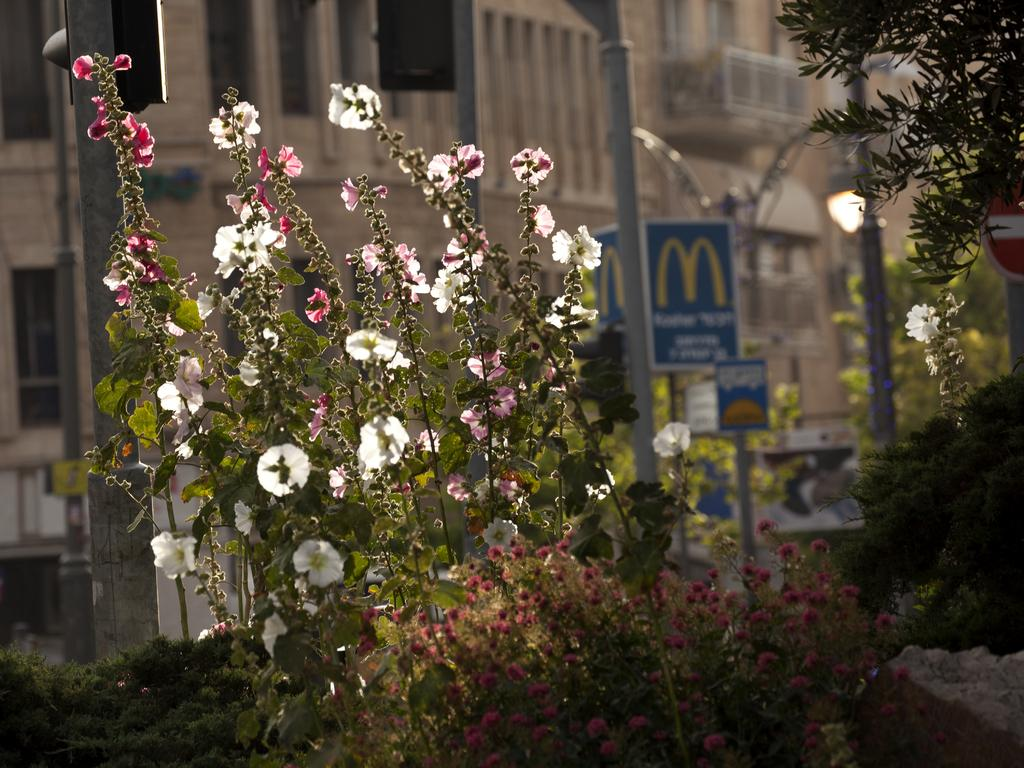What type of living organisms can be seen in the image? Plants and flowers are visible in the image. What can be seen in the background of the image? Buildings and boards can be seen in the background of the image. What objects are present in the image? Poles are present in the image. What type of vessel is being used to serve the meal in the image? There is no vessel or meal present in the image; it features plants, flowers, buildings, boards, and poles. What type of bottle can be seen in the image? There is no bottle present in the image. 